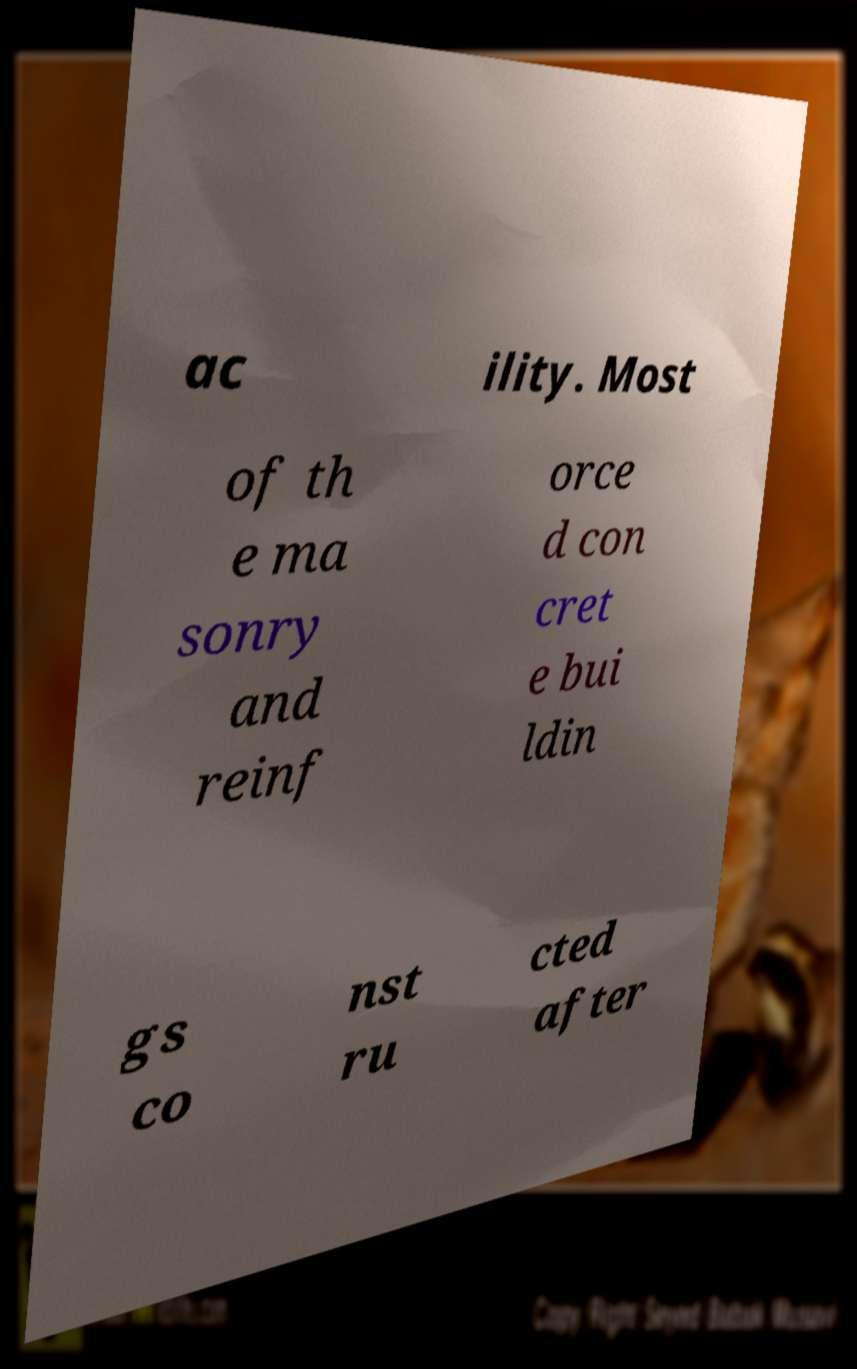Please identify and transcribe the text found in this image. ac ility. Most of th e ma sonry and reinf orce d con cret e bui ldin gs co nst ru cted after 